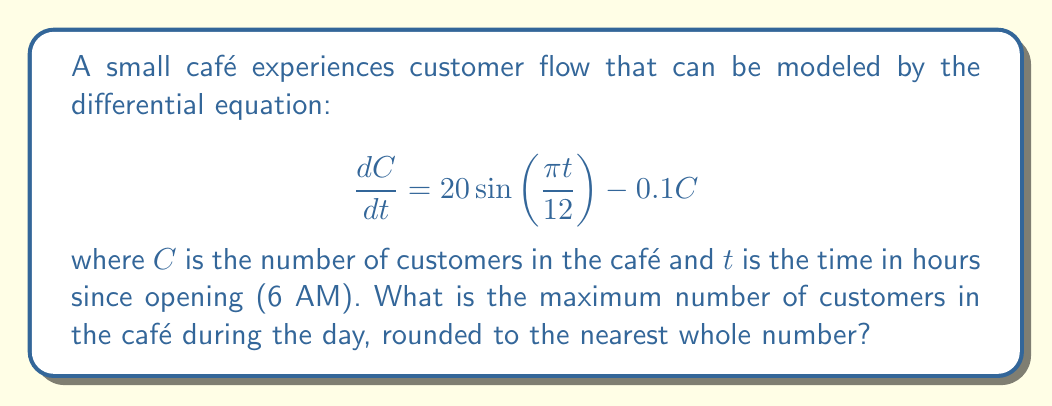Help me with this question. To find the maximum number of customers, we need to follow these steps:

1) The general solution to this differential equation is:
   $$C(t) = A\cos(\frac{\pi t}{12}) + B\sin(\frac{\pi t}{12}) + 200$$
   where $A$ and $B$ are constants determined by initial conditions.

2) The maximum value of this function occurs when the cosine and sine terms are at their peak. The maximum value of both sine and cosine is 1.

3) Therefore, the maximum value of $C(t)$ is:
   $$C_{max} = \sqrt{A^2 + B^2} + 200$$

4) To find $A$ and $B$, we substitute the general solution into the original differential equation:

   $$\frac{dC}{dt} = -\frac{\pi A}{12}\sin(\frac{\pi t}{12}) + \frac{\pi B}{12}\cos(\frac{\pi t}{12}) = 20\sin(\frac{\pi t}{12}) - 0.1(A\cos(\frac{\pi t}{12}) + B\sin(\frac{\pi t}{12}) + 200)$$

5) Equating coefficients:
   $$\frac{\pi B}{12} = 20$$
   $$-\frac{\pi A}{12} = -0.1B$$
   $$-0.1(200) = 0$$

6) Solving these equations:
   $$B = \frac{240}{\pi} \approx 76.39$$
   $$A = \frac{12 \cdot 0.1B}{\pi} \approx 2.91$$

7) Substituting into the equation for $C_{max}$:
   $$C_{max} = \sqrt{2.91^2 + 76.39^2} + 200 \approx 276.43$$

8) Rounding to the nearest whole number:
   $$C_{max} \approx 276$$
Answer: 276 customers 